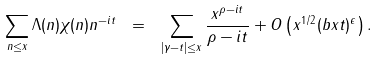<formula> <loc_0><loc_0><loc_500><loc_500>\sum _ { n \leq x } \Lambda ( n ) \chi ( n ) n ^ { - i t } \ = \ \sum _ { | \gamma - t | \leq x } \frac { x ^ { \rho - i t } } { \rho - i t } + O \left ( x ^ { 1 / 2 } ( b x t ) ^ { \epsilon } \right ) .</formula> 